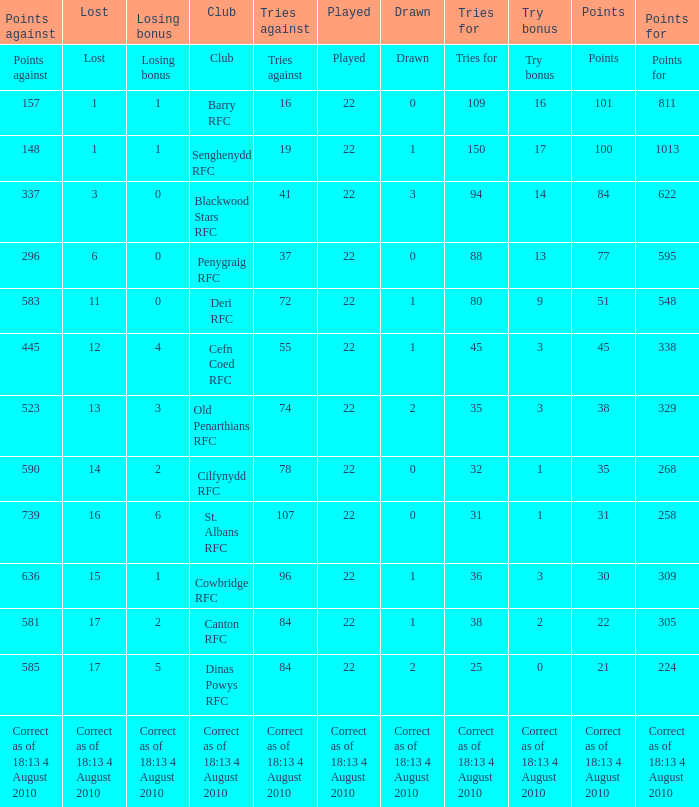Which team bears the distinction of having 22 points? Canton RFC. 